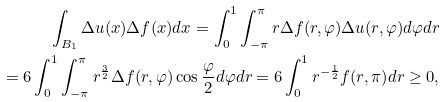Convert formula to latex. <formula><loc_0><loc_0><loc_500><loc_500>\int _ { B _ { 1 } } \Delta u ( x ) \Delta f ( x ) d x = \int _ { 0 } ^ { 1 } \int _ { - \pi } ^ { \pi } r \Delta f ( r , \varphi ) \Delta u ( r , \varphi ) d \varphi d r \\ = 6 \int _ { 0 } ^ { 1 } \int _ { - \pi } ^ { \pi } r ^ { \frac { 3 } { 2 } } \Delta f ( r , \varphi ) \cos \frac { \varphi } { 2 } d \varphi d r = 6 \int _ { 0 } ^ { 1 } { r ^ { - \frac { 1 } { 2 } } } { f ( r , \pi ) } d r \geq 0 ,</formula> 